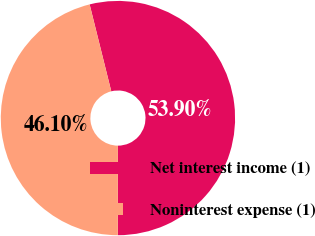Convert chart to OTSL. <chart><loc_0><loc_0><loc_500><loc_500><pie_chart><fcel>Net interest income (1)<fcel>Noninterest expense (1)<nl><fcel>53.9%<fcel>46.1%<nl></chart> 